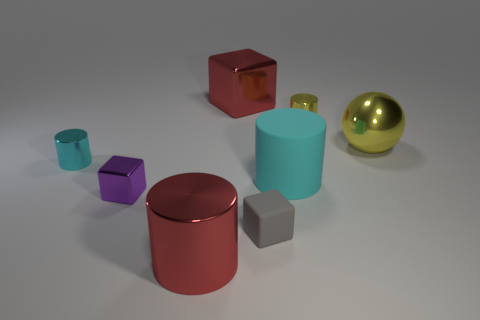Subtract 1 cylinders. How many cylinders are left? 3 Add 2 brown rubber things. How many objects exist? 10 Subtract all balls. How many objects are left? 7 Add 8 purple metal objects. How many purple metal objects are left? 9 Add 2 large matte cylinders. How many large matte cylinders exist? 3 Subtract 0 yellow cubes. How many objects are left? 8 Subtract all purple shiny objects. Subtract all small gray objects. How many objects are left? 6 